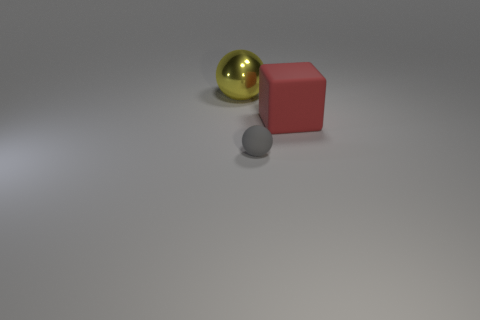Is there any other thing of the same color as the large rubber thing?
Your response must be concise. No. There is a object that is both left of the red matte block and behind the gray object; what is its shape?
Your response must be concise. Sphere. There is a sphere that is in front of the large yellow metal thing; how big is it?
Offer a very short reply. Small. How many large yellow things are behind the rubber thing that is behind the ball that is in front of the yellow metallic sphere?
Make the answer very short. 1. Are there any small gray rubber objects in front of the small matte thing?
Provide a succinct answer. No. How many other things are there of the same size as the yellow sphere?
Provide a short and direct response. 1. There is a thing that is both left of the matte block and in front of the yellow metallic thing; what material is it?
Your answer should be very brief. Rubber. There is a matte thing that is in front of the red rubber cube; is it the same shape as the big object that is in front of the yellow shiny thing?
Provide a succinct answer. No. Is there any other thing that has the same material as the small object?
Your answer should be very brief. Yes. There is a object that is on the right side of the ball that is in front of the sphere that is left of the small gray matte object; what is its shape?
Make the answer very short. Cube. 